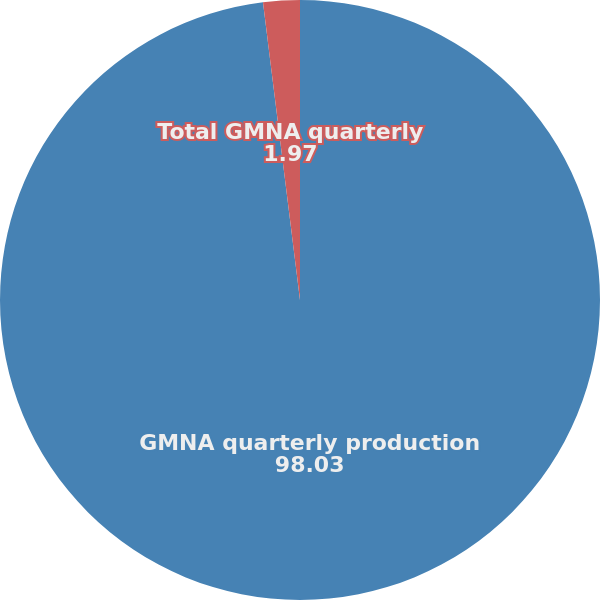<chart> <loc_0><loc_0><loc_500><loc_500><pie_chart><fcel>GMNA quarterly production<fcel>Total GMNA quarterly<nl><fcel>98.03%<fcel>1.97%<nl></chart> 